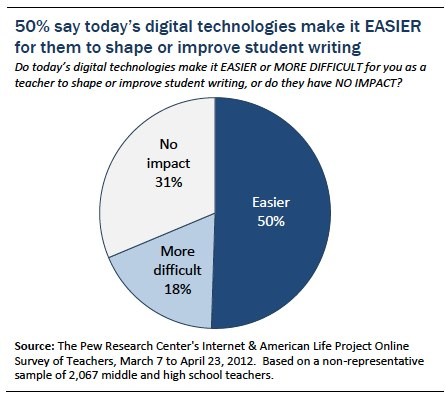List a handful of essential elements in this visual. The segment name 'Largest' is considered easier compared to the segment name 'Easier'. The ratio of the largest and smallest segment is approximately 2.77777778... 